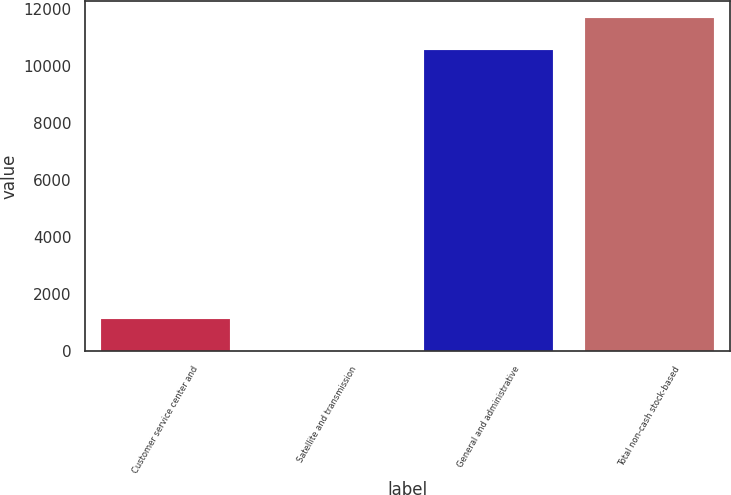Convert chart to OTSL. <chart><loc_0><loc_0><loc_500><loc_500><bar_chart><fcel>Customer service center and<fcel>Satellite and transmission<fcel>General and administrative<fcel>Total non-cash stock-based<nl><fcel>1134.2<fcel>7<fcel>10557<fcel>11684.2<nl></chart> 